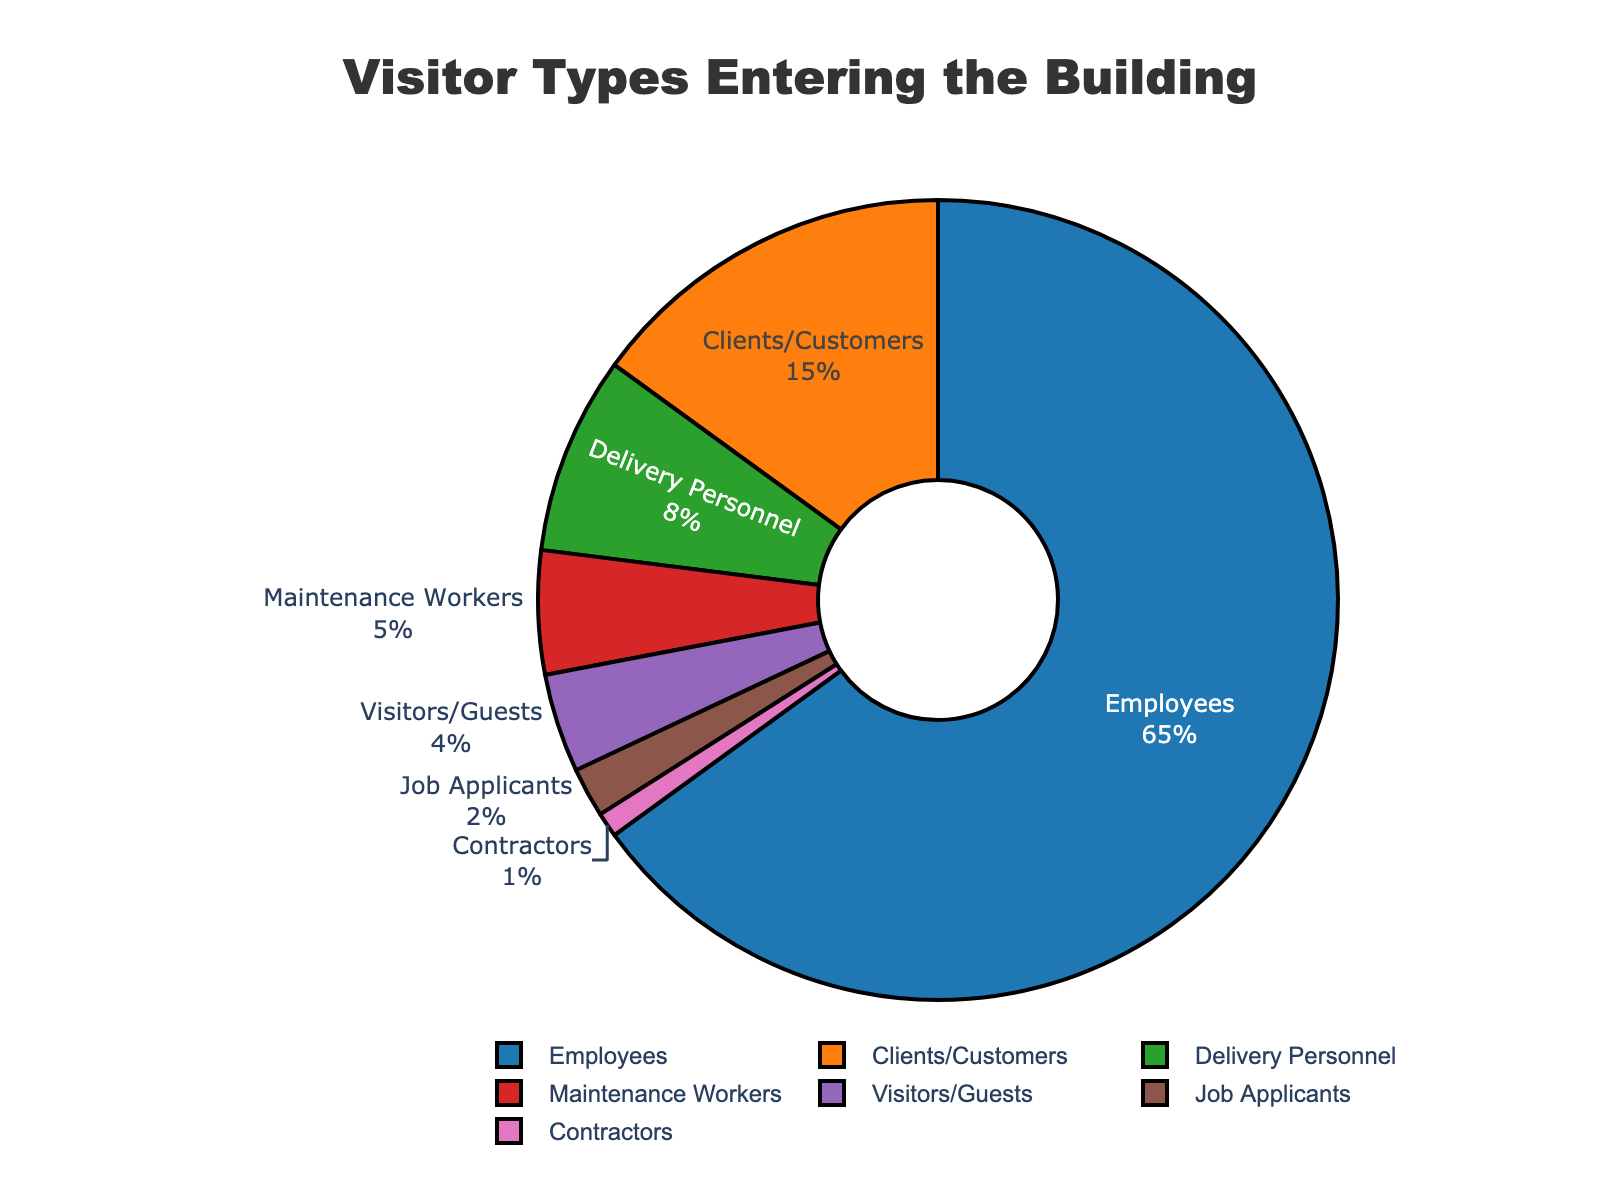What's the total percentage of non-employees entering the building? To find the total percentage of non-employees, sum the percentages of all categories except Employees (Clients/Customers, Delivery Personnel, Maintenance Workers, Visitors/Guests, Job Applicants, Contractors). This is 15 + 8 + 5 + 4 + 2 + 1 = 35%.
Answer: 35% Which category has the smallest percentage of visitors? Compare the percentages of all categories and identify the smallest value, which is Contractors at 1%.
Answer: Contractors Are there more Delivery Personnel or Maintenance Workers entering the building? Compare the percentages for Delivery Personnel (8%) and Maintenance Workers (5%). Delivery Personnel have a higher percentage.
Answer: Delivery Personnel What is the combined percentage of Clients/Customers and Job Applicants? Add the percentages of Clients/Customers (15%) and Job Applicants (2%). This is 15 + 2 = 17%.
Answer: 17% What percentage of the visitors are either Maintenance Workers or Visitors/Guests? Add the percentages of Maintenance Workers (5%) and Visitors/Guests (4%). This is 5 + 4 = 9%.
Answer: 9% Which category takes up more space in the chart: Visitors/Guests or Job Applicants? Compare the percentages for Visitors/Guests (4%) and Job Applicants (2%). Visitors/Guests occupy more space.
Answer: Visitors/Guests How much larger is the percentage of Employees compared to the combined percentage of all other categories? The percentage of Employees is 65%. Sum the percentages of all other categories (35%). Subtract the combined percentage of all other categories from the percentage of Employees: 65 - 35 = 30%.
Answer: 30% What is the difference in percentage between Clients/Customers and Contractors? Subtract the percentage of Contractors (1%) from the percentage of Clients/Customers (15%). This is 15 - 1 = 14%.
Answer: 14% What is the percentage difference between the highest and lowest visitor types? The highest percentage is Employees (65%), and the lowest is Contractors (1%). Subtract the lowest percentage from the highest: 65 - 1 = 64%.
Answer: 64% Which groups' percentages collectively add up to less than the percentage of Employees alone? Check the sum of various combinations of groups. Groups adding up to less than Employees (65%) are Clients/Customers, Delivery Personnel, Maintenance Workers, Visitors/Guests, Job Applicants, and Contractors (sum = 35%).
Answer: Clients/Customers, Delivery Personnel, Maintenance Workers, Visitors/Guests, Job Applicants, Contractors 